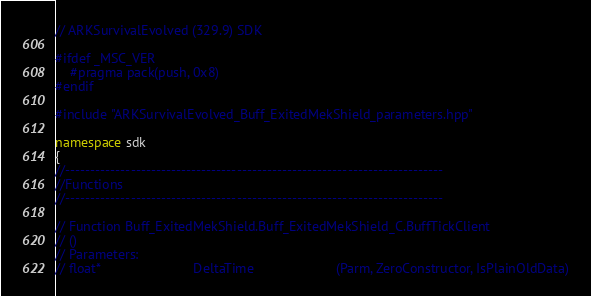<code> <loc_0><loc_0><loc_500><loc_500><_C++_>// ARKSurvivalEvolved (329.9) SDK

#ifdef _MSC_VER
	#pragma pack(push, 0x8)
#endif

#include "ARKSurvivalEvolved_Buff_ExitedMekShield_parameters.hpp"

namespace sdk
{
//---------------------------------------------------------------------------
//Functions
//---------------------------------------------------------------------------

// Function Buff_ExitedMekShield.Buff_ExitedMekShield_C.BuffTickClient
// ()
// Parameters:
// float*                         DeltaTime                      (Parm, ZeroConstructor, IsPlainOldData)
</code> 